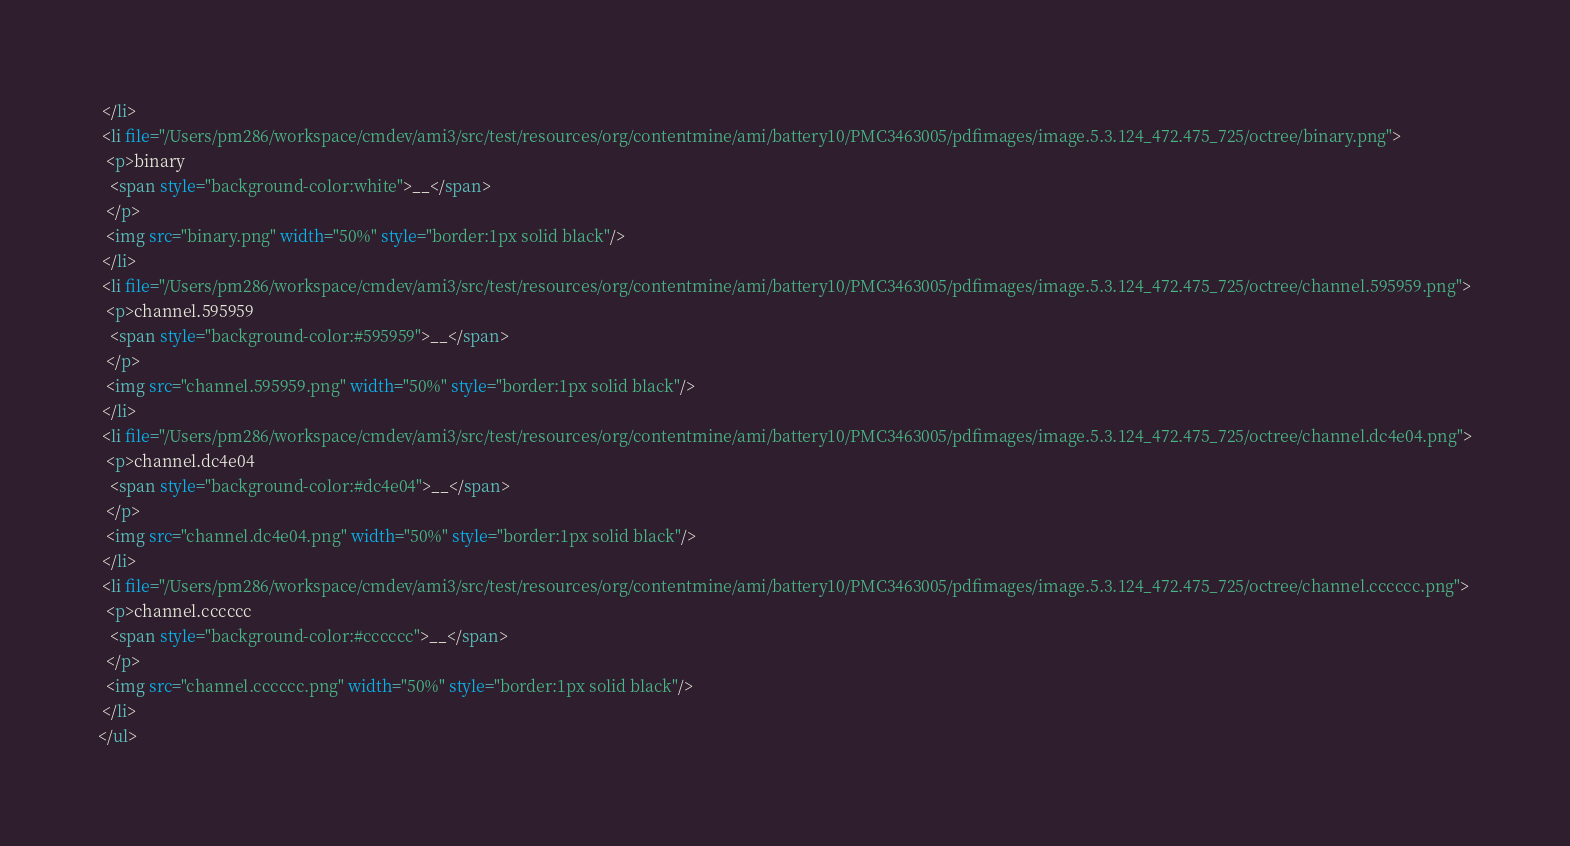Convert code to text. <code><loc_0><loc_0><loc_500><loc_500><_HTML_> </li>
 <li file="/Users/pm286/workspace/cmdev/ami3/src/test/resources/org/contentmine/ami/battery10/PMC3463005/pdfimages/image.5.3.124_472.475_725/octree/binary.png">
  <p>binary
   <span style="background-color:white">__</span>
  </p>
  <img src="binary.png" width="50%" style="border:1px solid black"/>
 </li>
 <li file="/Users/pm286/workspace/cmdev/ami3/src/test/resources/org/contentmine/ami/battery10/PMC3463005/pdfimages/image.5.3.124_472.475_725/octree/channel.595959.png">
  <p>channel.595959
   <span style="background-color:#595959">__</span>
  </p>
  <img src="channel.595959.png" width="50%" style="border:1px solid black"/>
 </li>
 <li file="/Users/pm286/workspace/cmdev/ami3/src/test/resources/org/contentmine/ami/battery10/PMC3463005/pdfimages/image.5.3.124_472.475_725/octree/channel.dc4e04.png">
  <p>channel.dc4e04
   <span style="background-color:#dc4e04">__</span>
  </p>
  <img src="channel.dc4e04.png" width="50%" style="border:1px solid black"/>
 </li>
 <li file="/Users/pm286/workspace/cmdev/ami3/src/test/resources/org/contentmine/ami/battery10/PMC3463005/pdfimages/image.5.3.124_472.475_725/octree/channel.cccccc.png">
  <p>channel.cccccc
   <span style="background-color:#cccccc">__</span>
  </p>
  <img src="channel.cccccc.png" width="50%" style="border:1px solid black"/>
 </li>
</ul>
</code> 